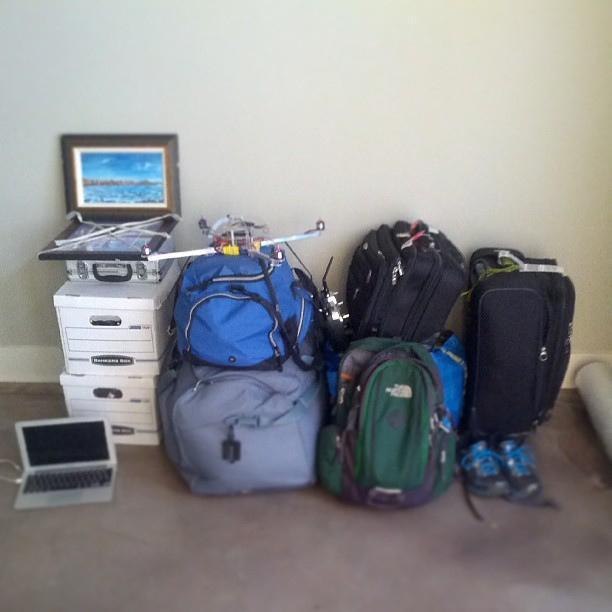How many laptops are there?
Give a very brief answer. 2. How many bags are blue?
Give a very brief answer. 2. How many pieces of unattended luggage are there?
Give a very brief answer. 5. How many laptops can you see?
Give a very brief answer. 2. How many suitcases are there?
Give a very brief answer. 2. How many handbags can you see?
Give a very brief answer. 1. 